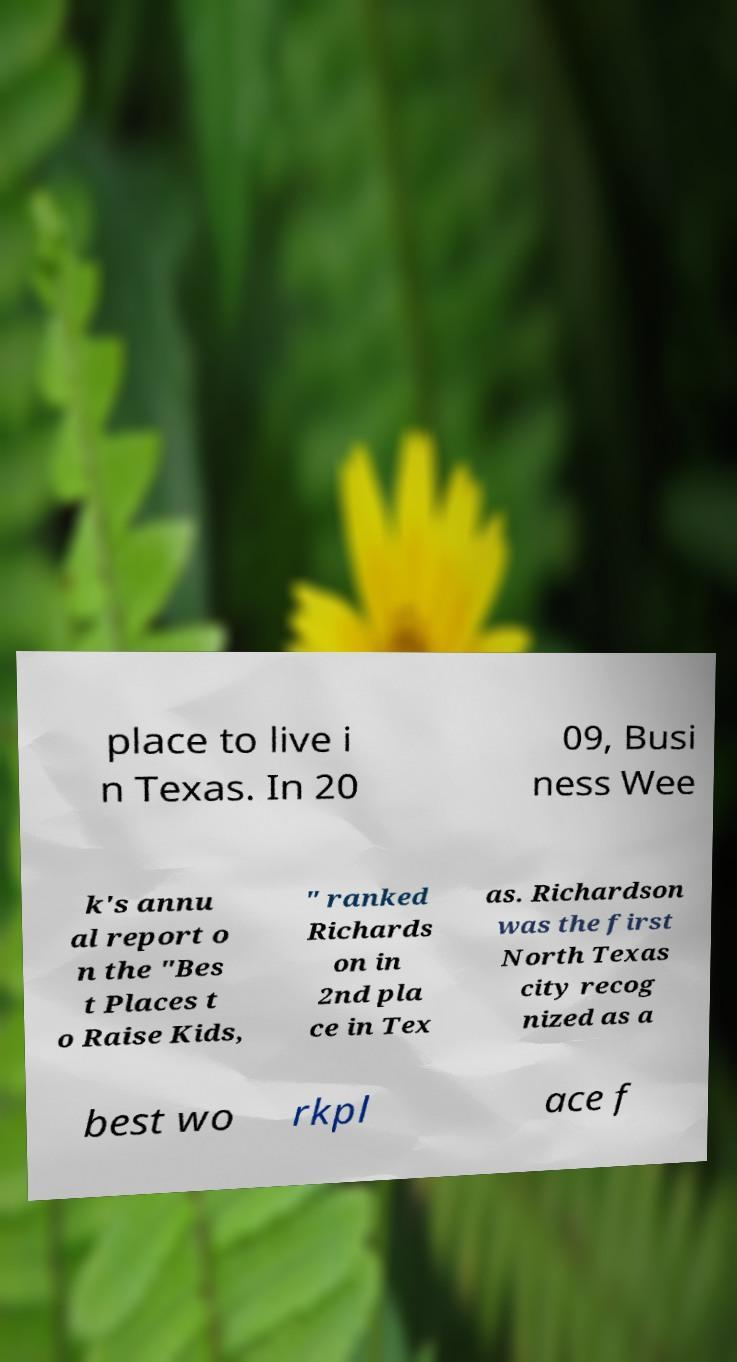What messages or text are displayed in this image? I need them in a readable, typed format. place to live i n Texas. In 20 09, Busi ness Wee k's annu al report o n the "Bes t Places t o Raise Kids, " ranked Richards on in 2nd pla ce in Tex as. Richardson was the first North Texas city recog nized as a best wo rkpl ace f 